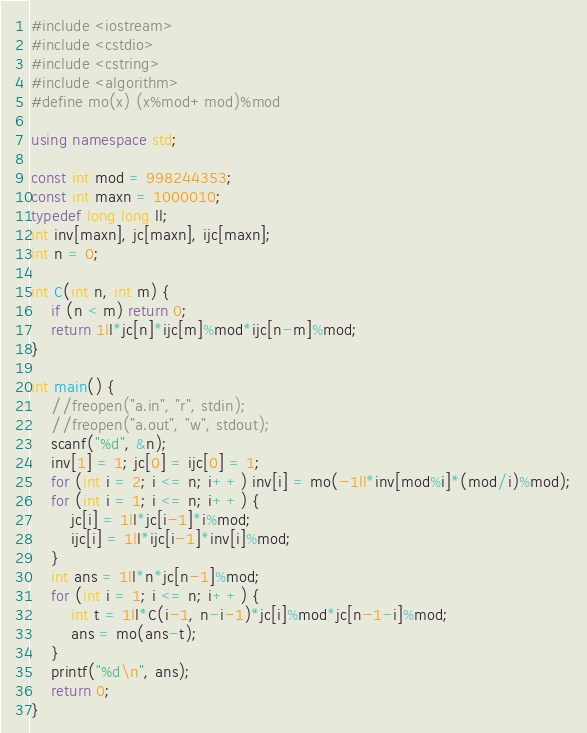Convert code to text. <code><loc_0><loc_0><loc_500><loc_500><_C++_>#include <iostream>
#include <cstdio>
#include <cstring>
#include <algorithm>
#define mo(x) (x%mod+mod)%mod

using namespace std;

const int mod = 998244353;
const int maxn = 1000010;
typedef long long ll;
int inv[maxn], jc[maxn], ijc[maxn];
int n = 0;

int C(int n, int m) {
    if (n < m) return 0;
    return 1ll*jc[n]*ijc[m]%mod*ijc[n-m]%mod;
}

int main() {
    //freopen("a.in", "r", stdin);
    //freopen("a.out", "w", stdout);
    scanf("%d", &n);
    inv[1] = 1; jc[0] = ijc[0] = 1;
    for (int i = 2; i <= n; i++) inv[i] = mo(-1ll*inv[mod%i]*(mod/i)%mod);
    for (int i = 1; i <= n; i++) {
        jc[i] = 1ll*jc[i-1]*i%mod;
        ijc[i] = 1ll*ijc[i-1]*inv[i]%mod;
    }
    int ans = 1ll*n*jc[n-1]%mod;
    for (int i = 1; i <= n; i++) {
        int t = 1ll*C(i-1, n-i-1)*jc[i]%mod*jc[n-1-i]%mod;
        ans = mo(ans-t);
    }
    printf("%d\n", ans);
    return 0;
}
</code> 